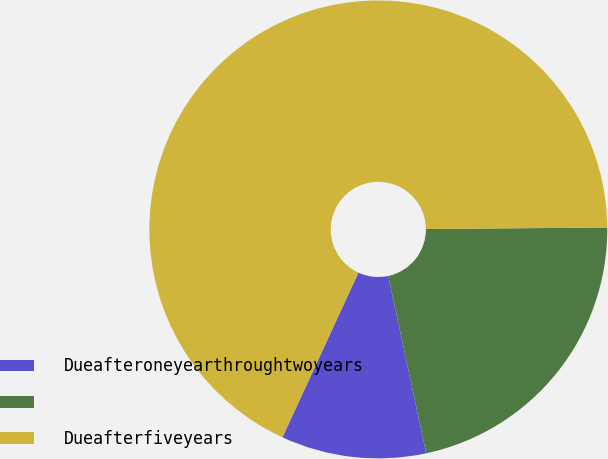Convert chart to OTSL. <chart><loc_0><loc_0><loc_500><loc_500><pie_chart><fcel>Dueafteroneyearthroughtwoyears<fcel>Unnamed: 1<fcel>Dueafterfiveyears<nl><fcel>10.23%<fcel>21.78%<fcel>67.99%<nl></chart> 